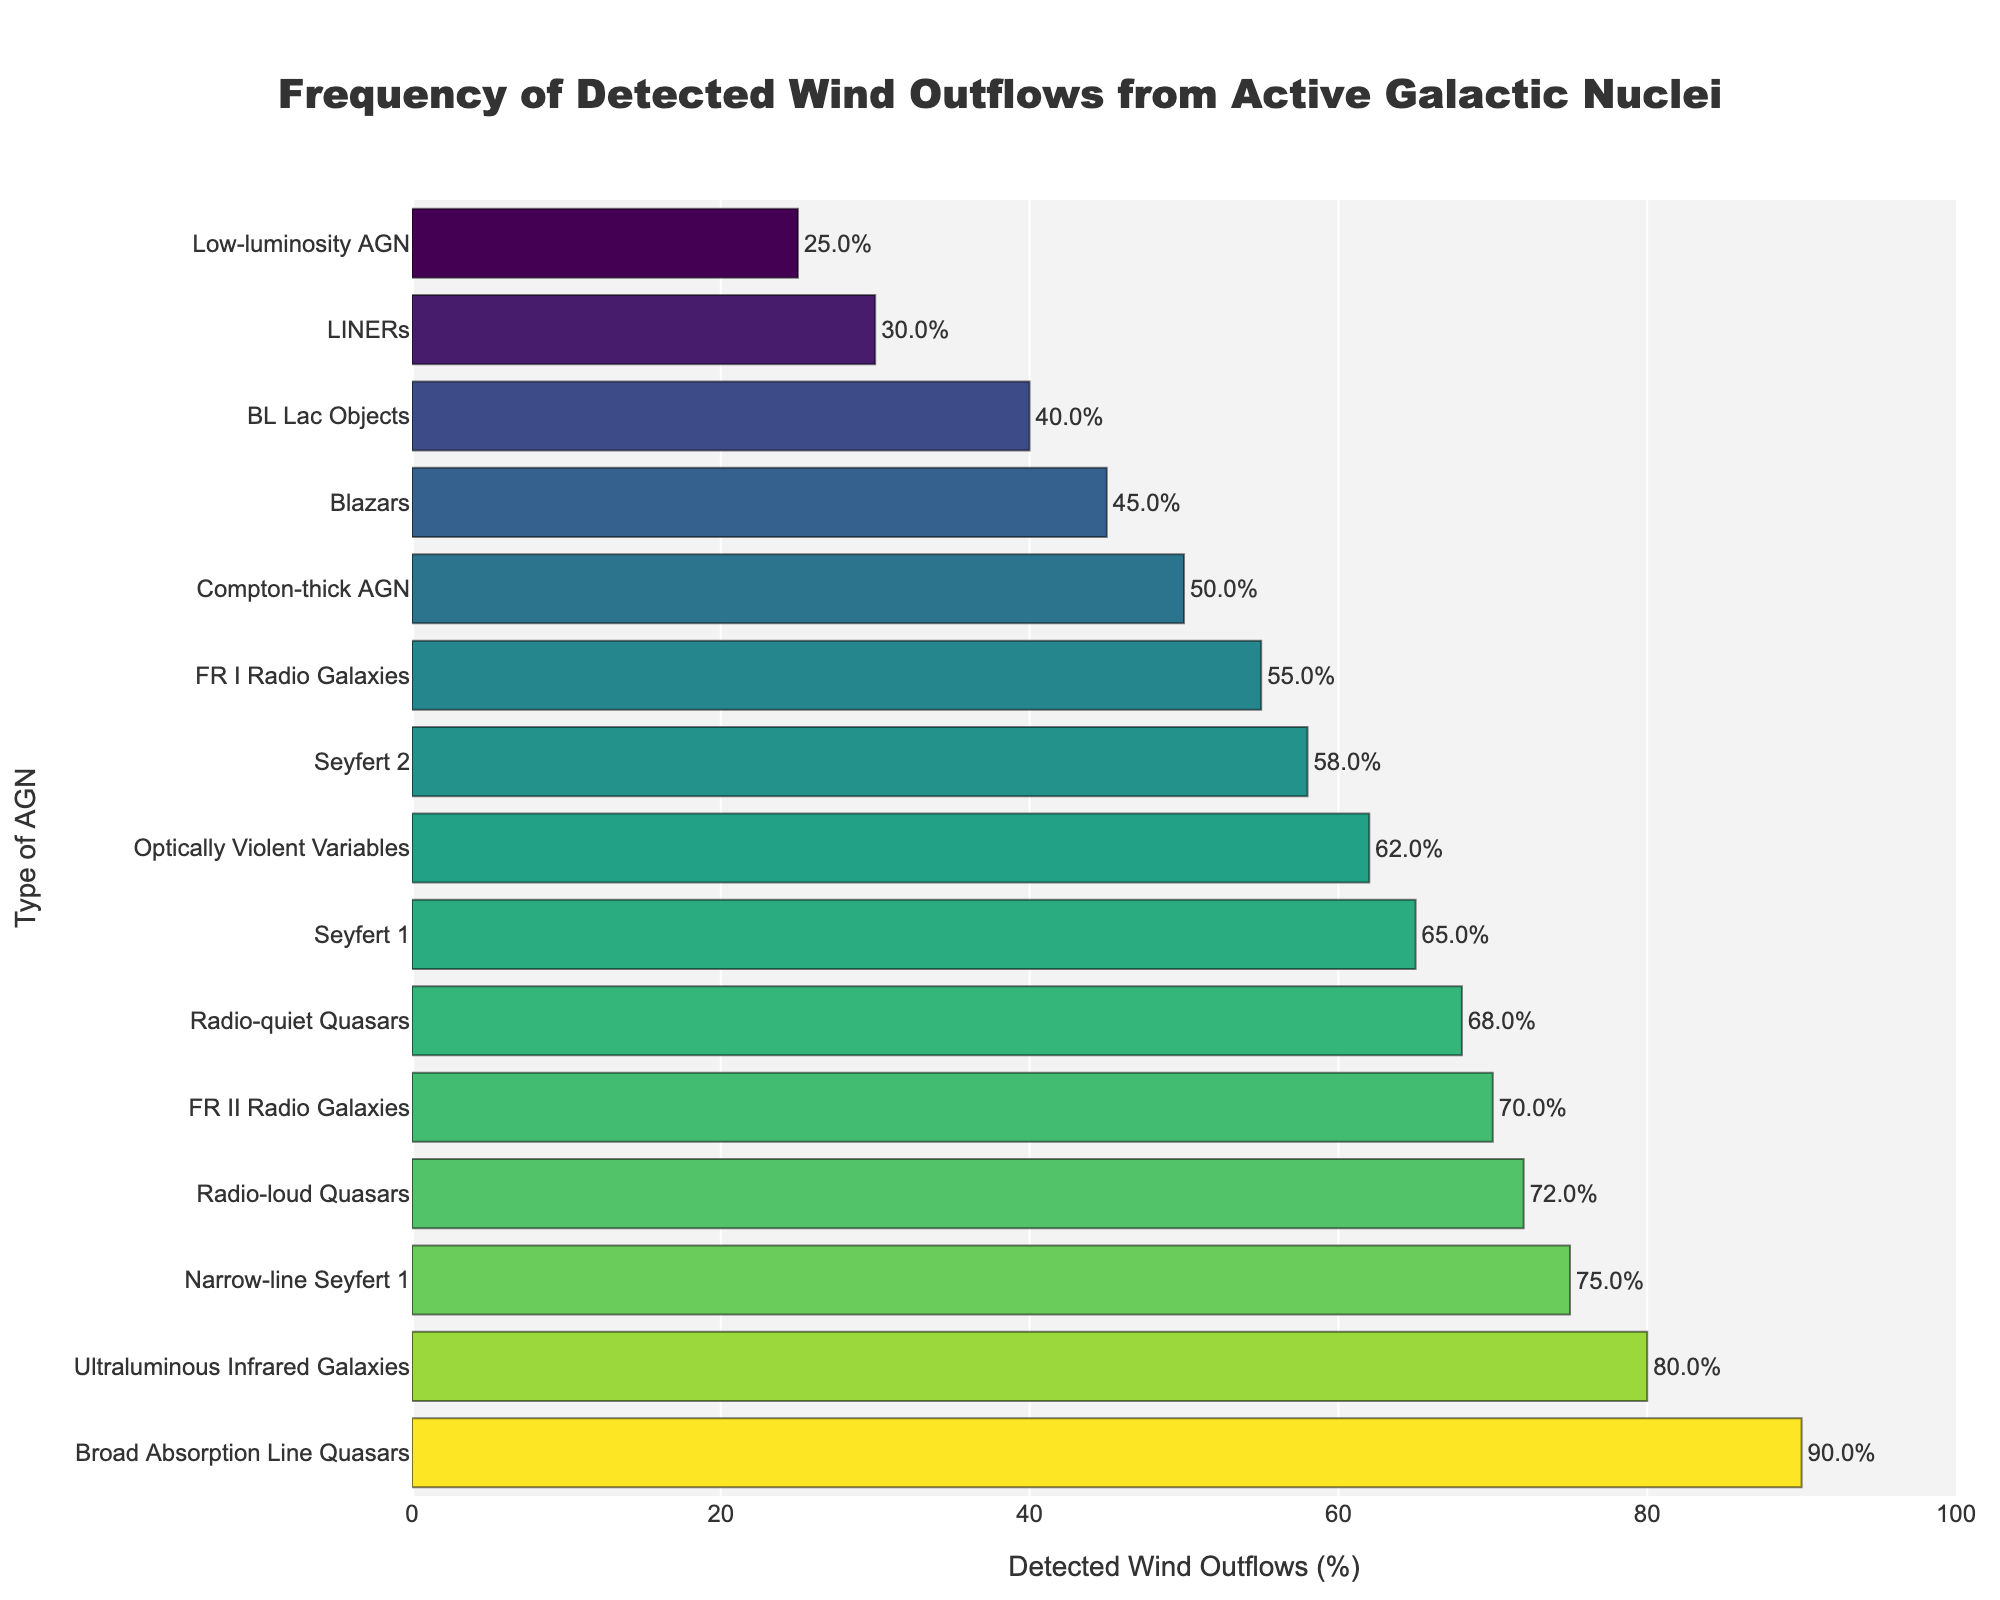Which type of AGN has the highest frequency of detected wind outflows? The graph shows the data for various types of AGNs sorted by the percentage of detected wind outflows. The bar representing "Broad Absorption Line Quasars" has the highest percentage value.
Answer: Broad Absorption Line Quasars What is the difference in detected wind outflows between "Broad Absorption Line Quasars" and "Low-luminosity AGN"? Extract the values from the bar chart: "Broad Absorption Line Quasars" is 90% and "Low-luminosity AGN" is 25%. Subtract the latter from the former: 90% - 25% = 65%.
Answer: 65% Which AGN type has the lowest detection frequency of wind outflows? The bar representing "Low-luminosity AGN" has the lowest value on the graph.
Answer: Low-luminosity AGN Are there more AGN types with detected wind outflows above or below 60%? Count the number of AGN types displayed in the chart with detected wind outflows above 60% and compare it to the count below 60%. There are 7 types above 60% and 8 types below 60%.
Answer: Below 60% How many AGN types have detected wind outflows above 70%? Count the bars with values greater than 70%: 3 AGN types ("Radio-loud Quasars," "Narrow-line Seyfert 1," "Broad Absorption Line Quasars").
Answer: 3 Which AGN has a higher frequency of detected wind outflows: "Seyfert 1" or "Seyfert 2"? "Seyfert 1" shows 65% while "Seyfert 2" shows 58%. Comparing the two values, "Seyfert 1" has a higher percentage.
Answer: Seyfert 1 What is the average frequency of detected wind outflows for "Blazars," "BL Lac Objects," and "LINERs"? Extract the percentages from the chart: "Blazars" is 45%, "BL Lac Objects" is 40%, and "LINERs" is 30%. Calculate the average: (45 + 40 + 30) / 3 = 38.33%.
Answer: 38.33% List all AGN types with detected wind outflows of 50% or more. Identify and list the AGN types whose bars have values of 50% or more: "Seyfert 1," "Seyfert 2," "Radio-loud Quasars," "Radio-quiet Quasars," "Broad Absorption Line Quasars," "Narrow-line Seyfert 1," "FR II Radio Galaxies," "Optically Violent Variables," "Ultraluminous Infrared Galaxies," and "Compton-thick AGN."
Answer: Seyfert 1, Seyfert 2, Radio-loud Quasars, Radio-quiet Quasars, Broad Absorption Line Quasars, Narrow-line Seyfert 1, FR II Radio Galaxies, Optically Violent Variables, Ultraluminous Infrared Galaxies, Compton-thick AGN 